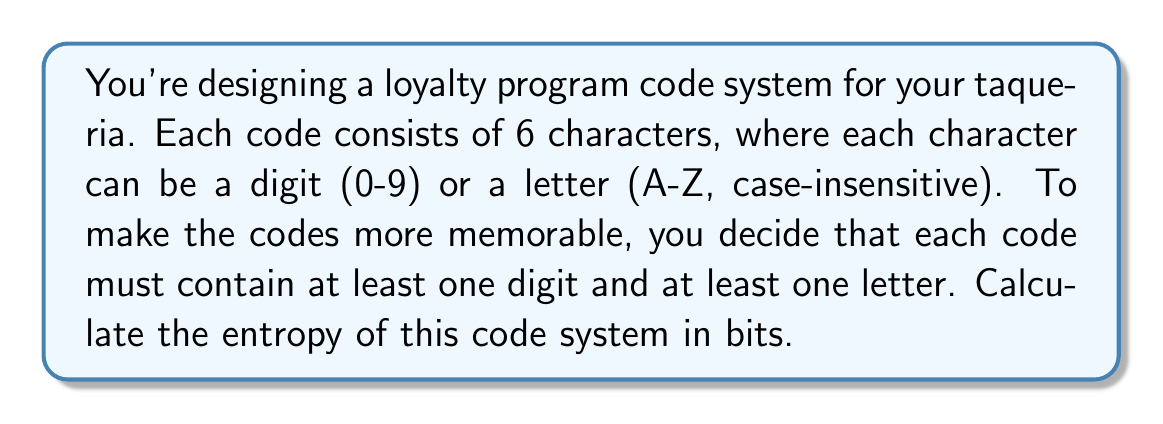Could you help me with this problem? Let's approach this step-by-step:

1) First, we need to calculate the total number of possible codes:

   - Total characters per code: 6
   - Possible characters: 10 digits + 26 letters = 36 options

2) However, we need to subtract the cases where all characters are digits or all are letters:

   $$ \text{Total combinations} = 36^6 - 10^6 - 26^6 $$

3) Now, let's calculate:

   $$ 36^6 = 2,176,782,336 $$
   $$ 10^6 = 1,000,000 $$
   $$ 26^6 = 308,915,776 $$

   $$ 2,176,782,336 - 1,000,000 - 308,915,776 = 1,866,866,560 $$

4) The entropy is calculated as the log base 2 of the number of possible outcomes:

   $$ \text{Entropy} = \log_2(1,866,866,560) $$

5) Using a calculator or programming language:

   $$ \log_2(1,866,866,560) \approx 30.7968 \text{ bits} $$
Answer: 30.7968 bits 